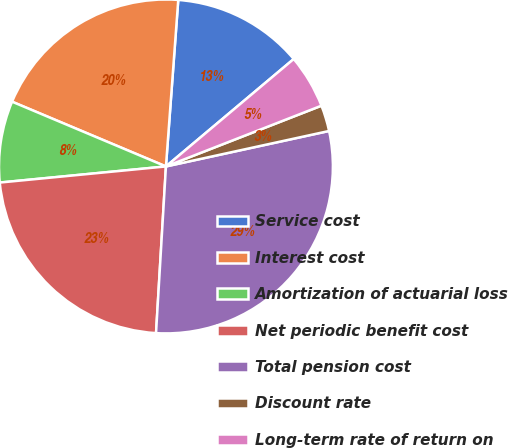Convert chart. <chart><loc_0><loc_0><loc_500><loc_500><pie_chart><fcel>Service cost<fcel>Interest cost<fcel>Amortization of actuarial loss<fcel>Net periodic benefit cost<fcel>Total pension cost<fcel>Discount rate<fcel>Long-term rate of return on<nl><fcel>12.7%<fcel>19.84%<fcel>7.88%<fcel>22.52%<fcel>29.36%<fcel>2.52%<fcel>5.2%<nl></chart> 